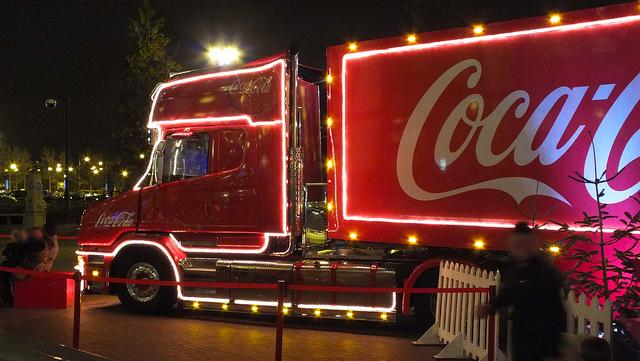What truck has festive lights?
Short answer required. Coca cola. Is this a fire truck?
Keep it brief. No. What Is separating the man from the truck?
Quick response, please. Fence. 